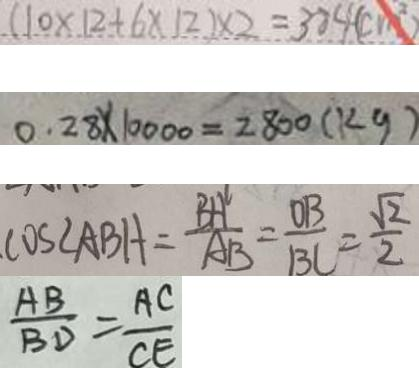<formula> <loc_0><loc_0><loc_500><loc_500>( 1 0 \times 1 2 + 6 \times 1 2 ) \times 2 = 3 8 4 ( c m ^ { 2 } ) 
 0 . 2 8 \times 1 0 0 0 0 = 2 8 0 0 ( k g ) 
 \cos \angle A B H = \frac { B H } { A B } = \frac { O B } { B C } = \frac { \sqrt { 2 } } { 2 } 
 \frac { A B } { B D } = \frac { A C } { C E }</formula> 